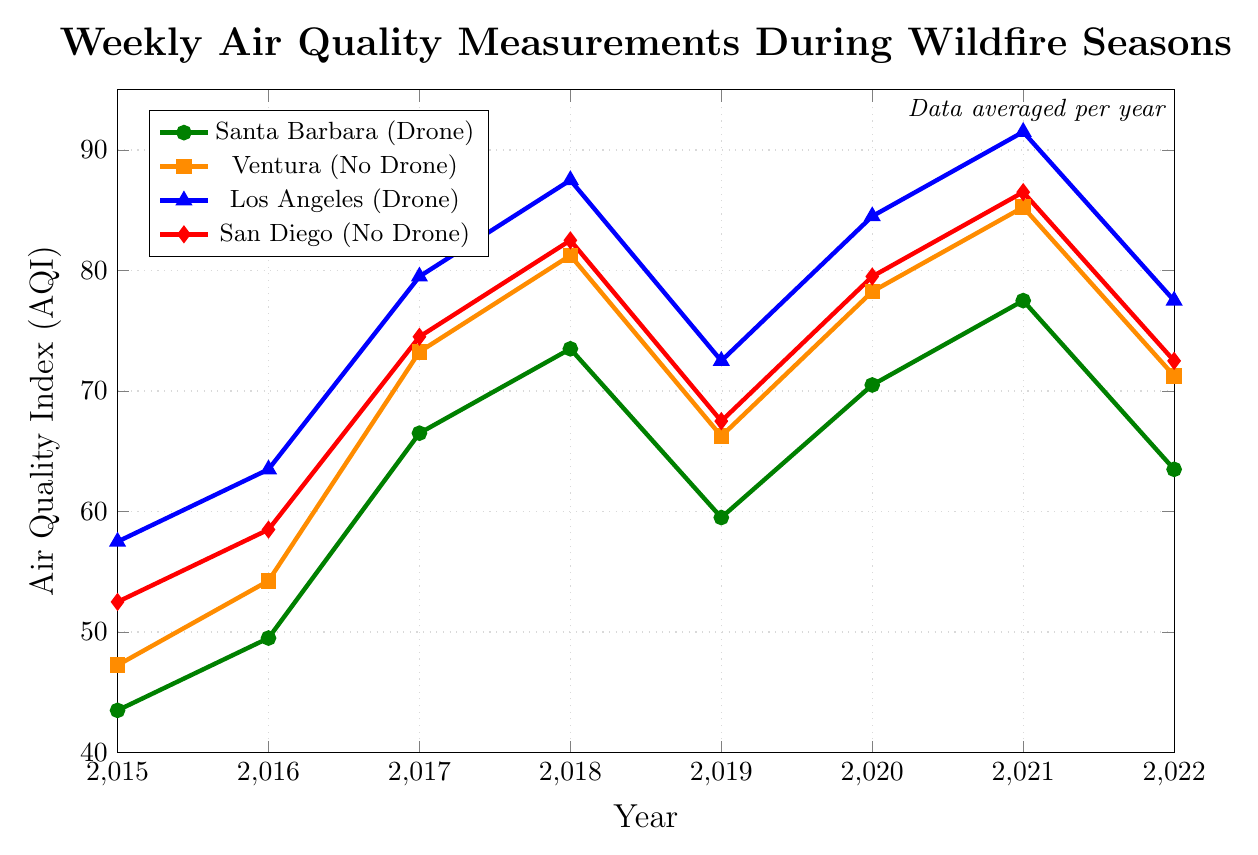What's the overall trend in the AQI for Los Angeles from 2015 to 2022? The AQI in Los Angeles shows an upward trend from 2015 (57.5) to a peak in 2021 (91.5) and then declines slightly in 2022 (77.5).
Answer: Upward trend with a slight decline in 2022 How does the AQI in Ventura in 2022 compare to the AQI in San Diego in the same year? In 2022, Ventura's AQI is 71.25 while San Diego's AQI is 72.5. Comparing the two values, San Diego's AQI is slightly higher.
Answer: San Diego's AQI is higher What was the average AQI for Ventura and San Diego in 2019? The AQI for Ventura in 2019 is 66.25, and for San Diego, it is 67.5. The average is calculated as (66.25 + 67.5) / 2 = 133.75 / 2 = 66.875.
Answer: 66.875 In which year did Santa Barbara have its highest AQI and what was the value? The highest AQI for Santa Barbara occurred in 2021 with a value of 77.5.
Answer: 2021, 77.5 Which city had the lowest AQI in 2016 and what was the value? Comparing the AQI values in 2016: Santa Barbara (49.5), Ventura (54.25), Los Angeles (63.5), and San Diego (58.5), Santa Barbara has the lowest AQI of 49.5.
Answer: Santa Barbara, 49.5 Did any year have the same AQI for both drone-monitored and no drone-monitored areas? If so, which year and what were the values? Checking if any year has identical AQI values between areas with drone monitoring and those without: No years have identical AQI values across the areas.
Answer: No What is the difference between the highest and lowest AQI in San Diego over the years shown? The highest AQI for San Diego is in 2021 (86.5) and the lowest is in 2015 (52.5), resulting in a difference of 86.5 - 52.5 = 34.
Answer: 34 Which year saw the largest increase in AQI for Ventura and what was the increase? Comparing AQIs for Ventura year on year: 2016 (54.25) - 2015 (47.25) = 7, 2017 (73.25) - 2016 (54.25) = 19, 2018 (81.25) - 2017 (73.25) = 8, 2019 (66.25) - 2018 (81.25) = -15, 2020 (78.25) - 2019 (66.25) = 12, 2021 (85.25) - 2020 (78.25) = 7, 2022 (71.25) - 2021 (85.25) = -14. The largest increase occurred in 2017 with 19.
Answer: 2017, 19 Is there a year where all cities had their AQI above 70? Reviewing each year: 2017 (Yes), 2018 (Yes), 2020 (Yes), 2021 (Yes), and 2015, 2016, 2019, and 2022 had at least one city's AQI below 70.
Answer: 2017, 2018, 2020, and 2021 